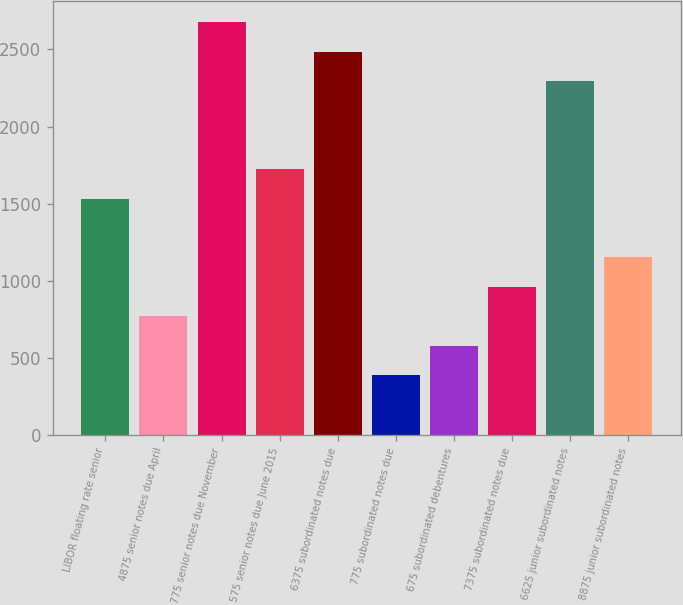Convert chart. <chart><loc_0><loc_0><loc_500><loc_500><bar_chart><fcel>LIBOR floating rate senior<fcel>4875 senior notes due April<fcel>775 senior notes due November<fcel>575 senior notes due June 2015<fcel>6375 subordinated notes due<fcel>775 subordinated notes due<fcel>675 subordinated debentures<fcel>7375 subordinated notes due<fcel>6625 junior subordinated notes<fcel>8875 junior subordinated notes<nl><fcel>1532.4<fcel>769.2<fcel>2677.2<fcel>1723.2<fcel>2486.4<fcel>387.6<fcel>578.4<fcel>960<fcel>2295.6<fcel>1150.8<nl></chart> 